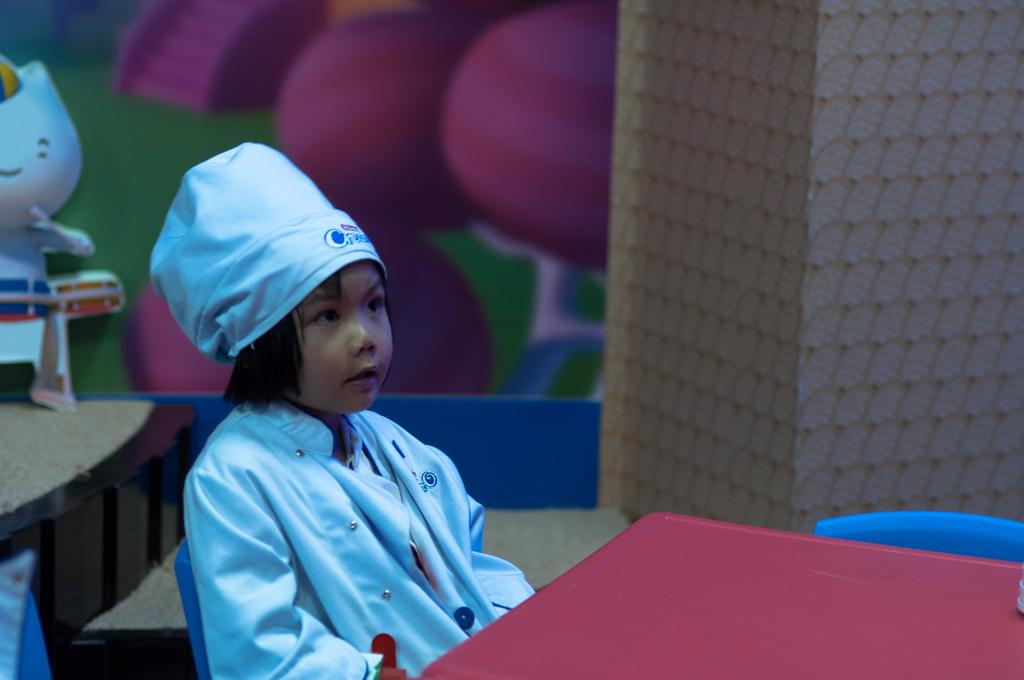What is the girl in the image doing? The girl is sitting on a chair in the image. What type of furniture is present in the image? There are tables and chairs in the image. What type of object can be seen in the image that is typically associated with play? There is a toy in the image. What can be seen in the background of the image? There is a wall visible in the background of the image. What type of flag is being discussed by the girl in the image? There is no flag present in the image, nor is there any indication of a discussion taking place. 